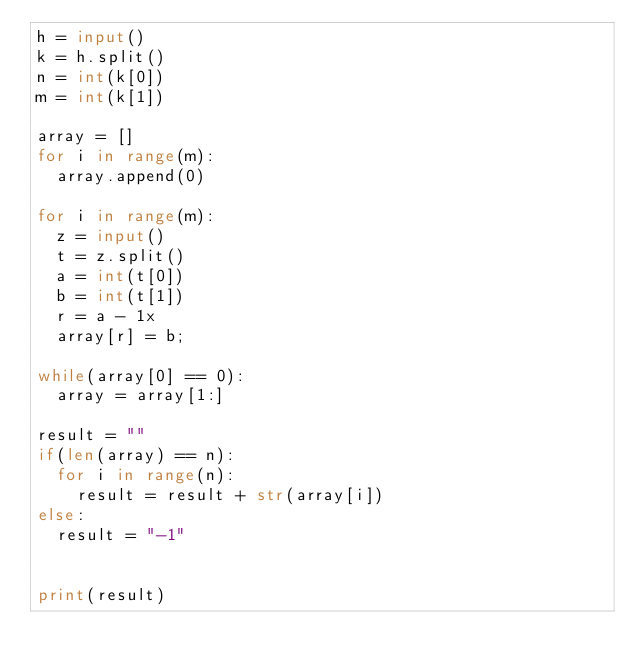<code> <loc_0><loc_0><loc_500><loc_500><_Python_>h = input()
k = h.split()
n = int(k[0])
m = int(k[1])

array = []
for i in range(m):
  array.append(0)

for i in range(m):
  z = input()
  t = z.split()
  a = int(t[0])
  b = int(t[1])
  r = a - 1x
  array[r] = b;

while(array[0] == 0):
  array = array[1:]

result = ""
if(len(array) == n):
  for i in range(n):
    result = result + str(array[i])
else:
  result = "-1"


print(result)
  
  </code> 